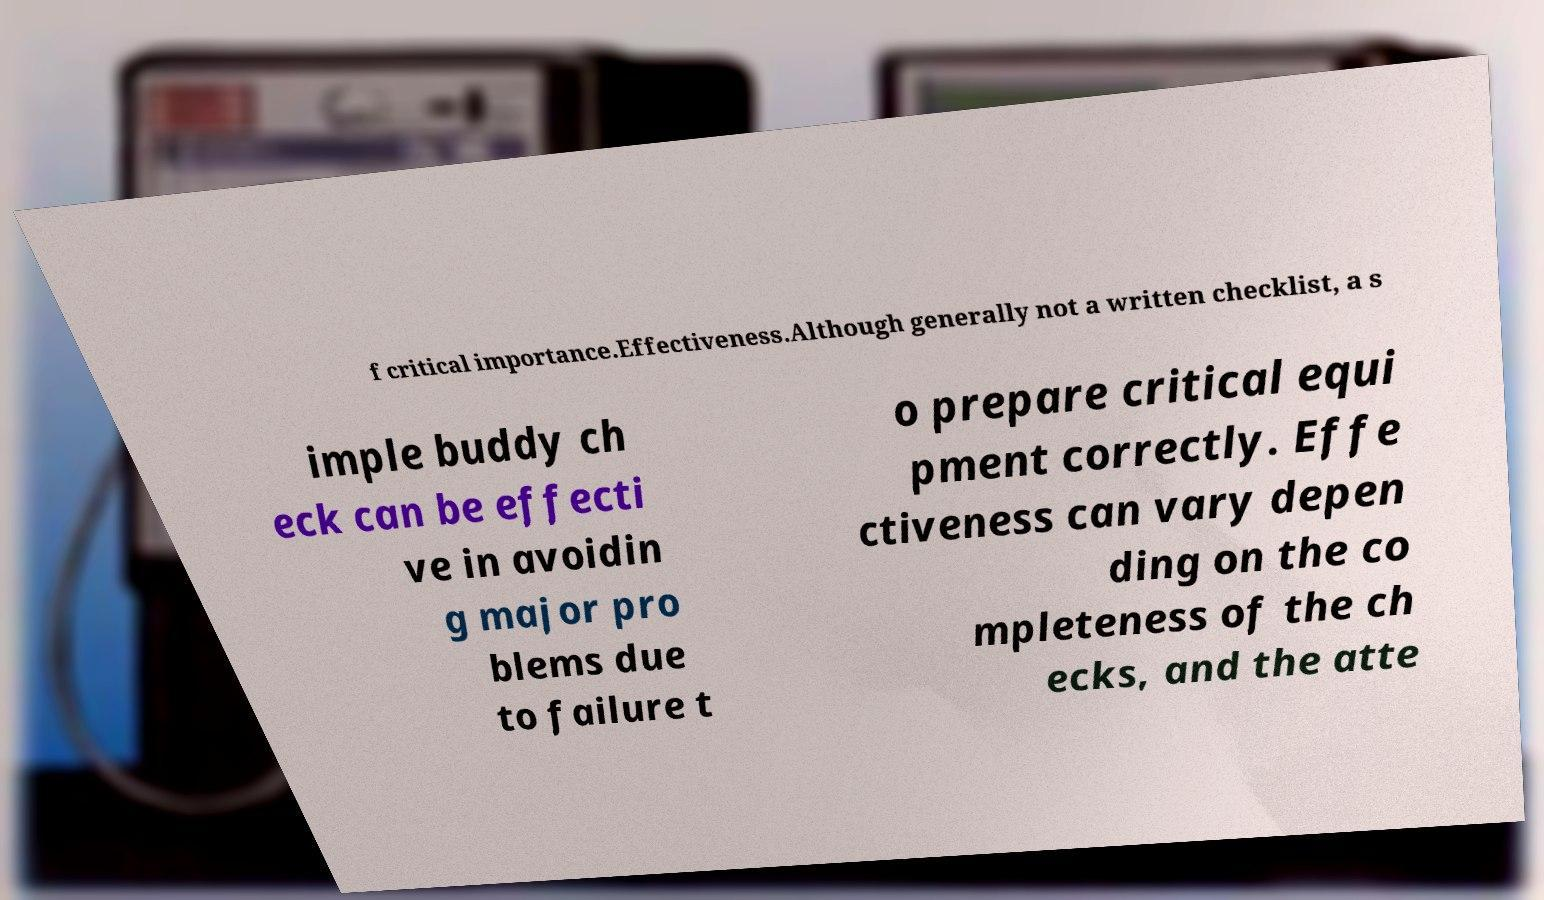I need the written content from this picture converted into text. Can you do that? f critical importance.Effectiveness.Although generally not a written checklist, a s imple buddy ch eck can be effecti ve in avoidin g major pro blems due to failure t o prepare critical equi pment correctly. Effe ctiveness can vary depen ding on the co mpleteness of the ch ecks, and the atte 